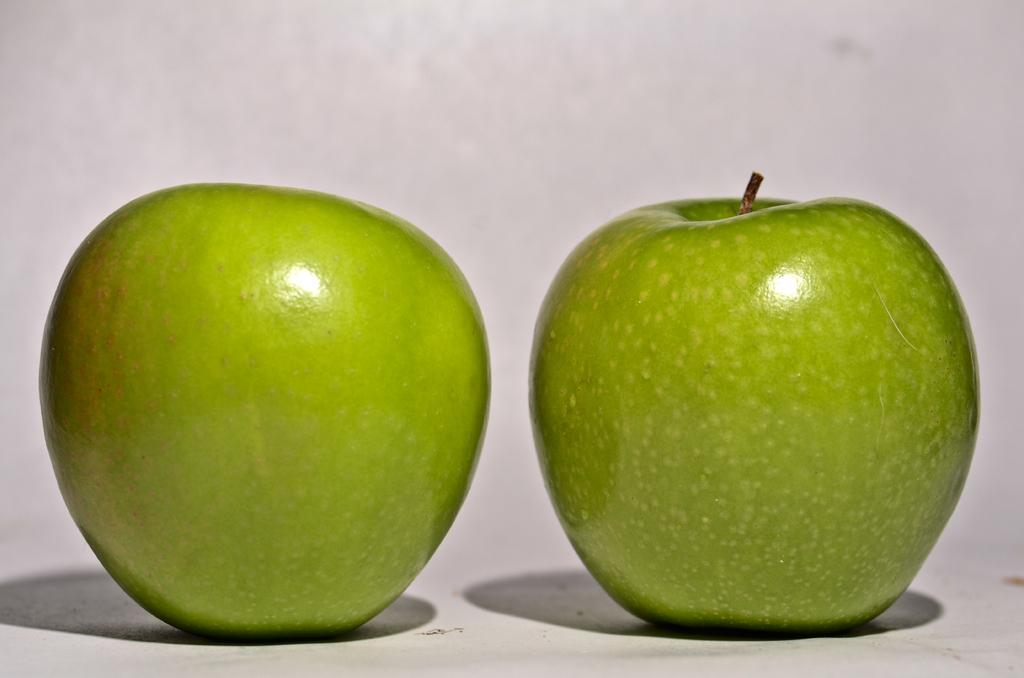What type of fruit is present in the image? There are two green apples in the image. What is the color of the apples? The apples are green. What is the surface on which the apples are placed? The apples are on a white surface. What type of fear can be seen on the apples in the image? There is no fear present on the apples in the image, as fear is an emotion experienced by living beings and not applicable to inanimate objects like apples. 